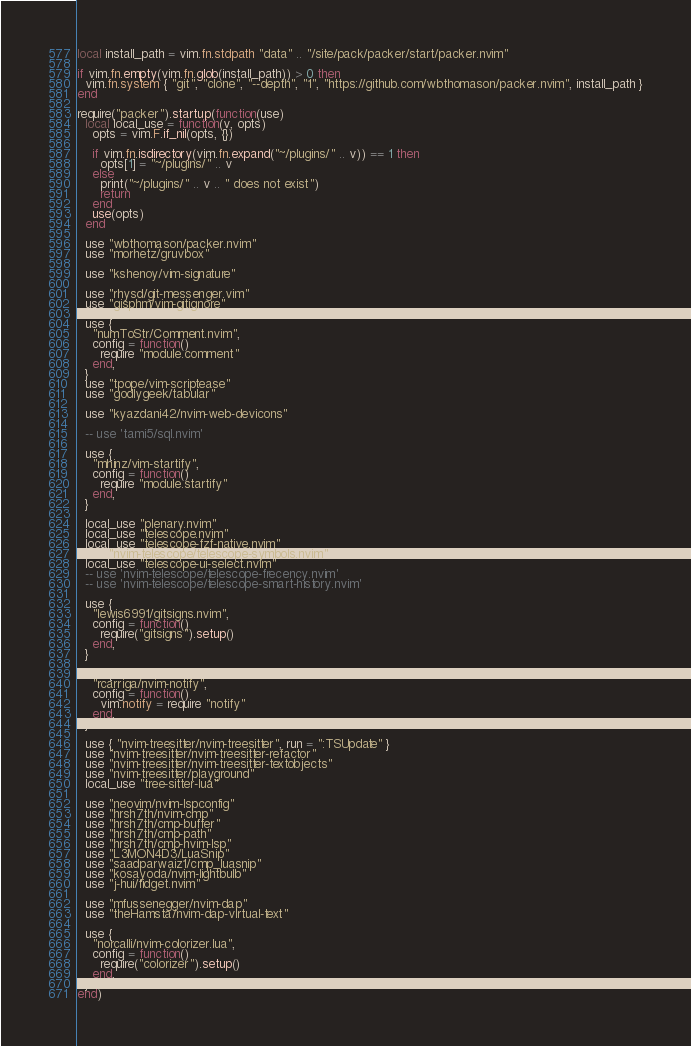<code> <loc_0><loc_0><loc_500><loc_500><_Lua_>local install_path = vim.fn.stdpath "data" .. "/site/pack/packer/start/packer.nvim"

if vim.fn.empty(vim.fn.glob(install_path)) > 0 then
  vim.fn.system { "git", "clone", "--depth", "1", "https://github.com/wbthomason/packer.nvim", install_path }
end

require("packer").startup(function(use)
  local local_use = function(v, opts)
    opts = vim.F.if_nil(opts, {})

    if vim.fn.isdirectory(vim.fn.expand("~/plugins/" .. v)) == 1 then
      opts[1] = "~/plugins/" .. v
    else
      print("~/plugins/" .. v .. " does not exist")
      return
    end
    use(opts)
  end

  use "wbthomason/packer.nvim"
  use "morhetz/gruvbox"

  use "kshenoy/vim-signature"

  use "rhysd/git-messenger.vim"
  use "gisphm/vim-gitignore"

  use {
    "numToStr/Comment.nvim",
    config = function()
      require "module.comment"
    end,
  }
  use "tpope/vim-scriptease"
  use "godlygeek/tabular"

  use "kyazdani42/nvim-web-devicons"

  -- use 'tami5/sql.nvim'

  use {
    "mhinz/vim-startify",
    config = function()
      require "module.startify"
    end,
  }

  local_use "plenary.nvim"
  local_use "telescope.nvim"
  local_use "telescope-fzf-native.nvim"
  use "nvim-telescope/telescope-symbols.nvim"
  local_use "telescope-ui-select.nvim"
  -- use 'nvim-telescope/telescope-frecency.nvim'
  -- use 'nvim-telescope/telescope-smart-history.nvim'

  use {
    "lewis6991/gitsigns.nvim",
    config = function()
      require("gitsigns").setup()
    end,
  }

  use {
    "rcarriga/nvim-notify",
    config = function()
      vim.notify = require "notify"
    end,
  }

  use { "nvim-treesitter/nvim-treesitter", run = ":TSUpdate" }
  use "nvim-treesitter/nvim-treesitter-refactor"
  use "nvim-treesitter/nvim-treesitter-textobjects"
  use "nvim-treesitter/playground"
  local_use "tree-sitter-lua"

  use "neovim/nvim-lspconfig"
  use "hrsh7th/nvim-cmp"
  use "hrsh7th/cmp-buffer"
  use "hrsh7th/cmp-path"
  use "hrsh7th/cmp-nvim-lsp"
  use "L3MON4D3/LuaSnip"
  use "saadparwaiz1/cmp_luasnip"
  use "kosayoda/nvim-lightbulb"
  use "j-hui/fidget.nvim"

  use "mfussenegger/nvim-dap"
  use "theHamsta/nvim-dap-virtual-text"

  use {
    "norcalli/nvim-colorizer.lua",
    config = function()
      require("colorizer").setup()
    end,
  }
end)
</code> 